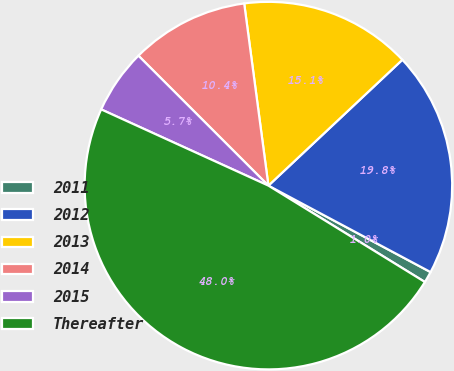Convert chart. <chart><loc_0><loc_0><loc_500><loc_500><pie_chart><fcel>2011<fcel>2012<fcel>2013<fcel>2014<fcel>2015<fcel>Thereafter<nl><fcel>0.99%<fcel>19.8%<fcel>15.1%<fcel>10.4%<fcel>5.69%<fcel>48.02%<nl></chart> 